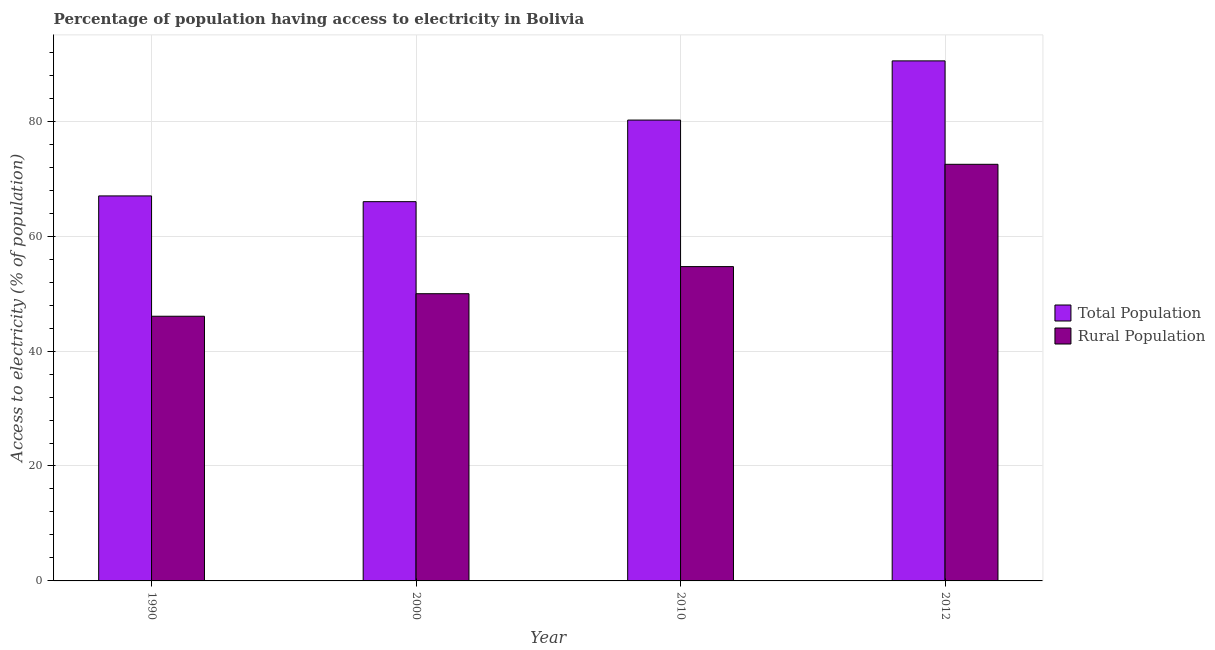How many different coloured bars are there?
Your answer should be compact. 2. Are the number of bars per tick equal to the number of legend labels?
Your answer should be compact. Yes. Are the number of bars on each tick of the X-axis equal?
Your answer should be very brief. Yes. How many bars are there on the 1st tick from the right?
Your answer should be very brief. 2. What is the label of the 3rd group of bars from the left?
Your answer should be compact. 2010. In how many cases, is the number of bars for a given year not equal to the number of legend labels?
Your answer should be very brief. 0. What is the percentage of rural population having access to electricity in 2000?
Your response must be concise. 49.98. Across all years, what is the maximum percentage of population having access to electricity?
Provide a succinct answer. 90.5. Across all years, what is the minimum percentage of rural population having access to electricity?
Offer a terse response. 46.06. What is the total percentage of population having access to electricity in the graph?
Ensure brevity in your answer.  303.7. What is the difference between the percentage of rural population having access to electricity in 1990 and that in 2012?
Your answer should be very brief. -26.44. What is the difference between the percentage of population having access to electricity in 2012 and the percentage of rural population having access to electricity in 2010?
Provide a short and direct response. 10.3. What is the average percentage of rural population having access to electricity per year?
Ensure brevity in your answer.  55.81. In the year 2010, what is the difference between the percentage of population having access to electricity and percentage of rural population having access to electricity?
Provide a succinct answer. 0. In how many years, is the percentage of population having access to electricity greater than 48 %?
Your answer should be compact. 4. What is the ratio of the percentage of rural population having access to electricity in 1990 to that in 2000?
Provide a succinct answer. 0.92. Is the percentage of population having access to electricity in 1990 less than that in 2010?
Give a very brief answer. Yes. Is the difference between the percentage of population having access to electricity in 1990 and 2010 greater than the difference between the percentage of rural population having access to electricity in 1990 and 2010?
Your response must be concise. No. What is the difference between the highest and the second highest percentage of population having access to electricity?
Offer a terse response. 10.3. What is the difference between the highest and the lowest percentage of rural population having access to electricity?
Keep it short and to the point. 26.44. In how many years, is the percentage of rural population having access to electricity greater than the average percentage of rural population having access to electricity taken over all years?
Offer a very short reply. 1. What does the 2nd bar from the left in 2010 represents?
Keep it short and to the point. Rural Population. What does the 1st bar from the right in 2000 represents?
Provide a short and direct response. Rural Population. How many bars are there?
Ensure brevity in your answer.  8. Are all the bars in the graph horizontal?
Offer a terse response. No. What is the difference between two consecutive major ticks on the Y-axis?
Provide a short and direct response. 20. Does the graph contain grids?
Your response must be concise. Yes. How are the legend labels stacked?
Offer a very short reply. Vertical. What is the title of the graph?
Provide a succinct answer. Percentage of population having access to electricity in Bolivia. Does "From production" appear as one of the legend labels in the graph?
Your answer should be compact. No. What is the label or title of the X-axis?
Make the answer very short. Year. What is the label or title of the Y-axis?
Provide a succinct answer. Access to electricity (% of population). What is the Access to electricity (% of population) in Total Population in 1990?
Ensure brevity in your answer.  67. What is the Access to electricity (% of population) of Rural Population in 1990?
Offer a very short reply. 46.06. What is the Access to electricity (% of population) of Rural Population in 2000?
Provide a short and direct response. 49.98. What is the Access to electricity (% of population) of Total Population in 2010?
Ensure brevity in your answer.  80.2. What is the Access to electricity (% of population) in Rural Population in 2010?
Give a very brief answer. 54.7. What is the Access to electricity (% of population) of Total Population in 2012?
Give a very brief answer. 90.5. What is the Access to electricity (% of population) of Rural Population in 2012?
Your answer should be very brief. 72.5. Across all years, what is the maximum Access to electricity (% of population) in Total Population?
Give a very brief answer. 90.5. Across all years, what is the maximum Access to electricity (% of population) of Rural Population?
Your response must be concise. 72.5. Across all years, what is the minimum Access to electricity (% of population) of Rural Population?
Your response must be concise. 46.06. What is the total Access to electricity (% of population) in Total Population in the graph?
Keep it short and to the point. 303.7. What is the total Access to electricity (% of population) of Rural Population in the graph?
Offer a terse response. 223.24. What is the difference between the Access to electricity (% of population) in Rural Population in 1990 and that in 2000?
Give a very brief answer. -3.92. What is the difference between the Access to electricity (% of population) in Rural Population in 1990 and that in 2010?
Give a very brief answer. -8.64. What is the difference between the Access to electricity (% of population) of Total Population in 1990 and that in 2012?
Make the answer very short. -23.5. What is the difference between the Access to electricity (% of population) of Rural Population in 1990 and that in 2012?
Your response must be concise. -26.44. What is the difference between the Access to electricity (% of population) in Total Population in 2000 and that in 2010?
Your response must be concise. -14.2. What is the difference between the Access to electricity (% of population) in Rural Population in 2000 and that in 2010?
Ensure brevity in your answer.  -4.72. What is the difference between the Access to electricity (% of population) in Total Population in 2000 and that in 2012?
Your answer should be compact. -24.5. What is the difference between the Access to electricity (% of population) of Rural Population in 2000 and that in 2012?
Keep it short and to the point. -22.52. What is the difference between the Access to electricity (% of population) in Total Population in 2010 and that in 2012?
Keep it short and to the point. -10.3. What is the difference between the Access to electricity (% of population) in Rural Population in 2010 and that in 2012?
Offer a terse response. -17.8. What is the difference between the Access to electricity (% of population) of Total Population in 1990 and the Access to electricity (% of population) of Rural Population in 2000?
Give a very brief answer. 17.02. What is the difference between the Access to electricity (% of population) of Total Population in 2010 and the Access to electricity (% of population) of Rural Population in 2012?
Provide a short and direct response. 7.7. What is the average Access to electricity (% of population) in Total Population per year?
Give a very brief answer. 75.92. What is the average Access to electricity (% of population) in Rural Population per year?
Your response must be concise. 55.81. In the year 1990, what is the difference between the Access to electricity (% of population) of Total Population and Access to electricity (% of population) of Rural Population?
Your answer should be very brief. 20.94. In the year 2000, what is the difference between the Access to electricity (% of population) of Total Population and Access to electricity (% of population) of Rural Population?
Your answer should be very brief. 16.02. In the year 2010, what is the difference between the Access to electricity (% of population) of Total Population and Access to electricity (% of population) of Rural Population?
Your answer should be compact. 25.5. What is the ratio of the Access to electricity (% of population) in Total Population in 1990 to that in 2000?
Offer a terse response. 1.02. What is the ratio of the Access to electricity (% of population) of Rural Population in 1990 to that in 2000?
Keep it short and to the point. 0.92. What is the ratio of the Access to electricity (% of population) in Total Population in 1990 to that in 2010?
Your response must be concise. 0.84. What is the ratio of the Access to electricity (% of population) of Rural Population in 1990 to that in 2010?
Your response must be concise. 0.84. What is the ratio of the Access to electricity (% of population) of Total Population in 1990 to that in 2012?
Provide a succinct answer. 0.74. What is the ratio of the Access to electricity (% of population) of Rural Population in 1990 to that in 2012?
Your response must be concise. 0.64. What is the ratio of the Access to electricity (% of population) in Total Population in 2000 to that in 2010?
Give a very brief answer. 0.82. What is the ratio of the Access to electricity (% of population) of Rural Population in 2000 to that in 2010?
Offer a terse response. 0.91. What is the ratio of the Access to electricity (% of population) in Total Population in 2000 to that in 2012?
Provide a short and direct response. 0.73. What is the ratio of the Access to electricity (% of population) in Rural Population in 2000 to that in 2012?
Your answer should be compact. 0.69. What is the ratio of the Access to electricity (% of population) of Total Population in 2010 to that in 2012?
Your answer should be compact. 0.89. What is the ratio of the Access to electricity (% of population) in Rural Population in 2010 to that in 2012?
Offer a very short reply. 0.75. What is the difference between the highest and the lowest Access to electricity (% of population) in Total Population?
Provide a succinct answer. 24.5. What is the difference between the highest and the lowest Access to electricity (% of population) in Rural Population?
Provide a succinct answer. 26.44. 